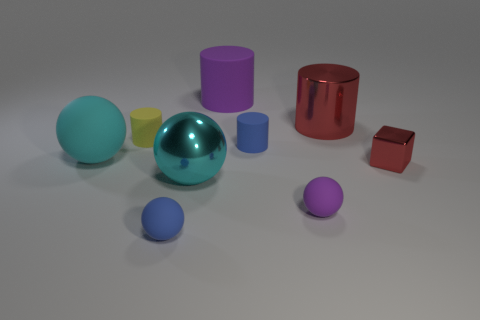What is the material of the small cylinder that is left of the big cyan ball that is in front of the big cyan thing that is left of the tiny yellow cylinder?
Your response must be concise. Rubber. There is a small blue thing behind the big rubber object left of the tiny yellow matte cylinder; what is it made of?
Make the answer very short. Rubber. Is the number of shiny cylinders that are left of the metallic cylinder less than the number of big cyan spheres?
Offer a terse response. Yes. What shape is the purple matte thing in front of the big red metallic cylinder?
Give a very brief answer. Sphere. Do the blue cylinder and the thing that is to the left of the yellow rubber cylinder have the same size?
Provide a succinct answer. No. Is there a tiny blue cylinder made of the same material as the purple ball?
Make the answer very short. Yes. How many cylinders are large purple matte things or large cyan matte things?
Provide a succinct answer. 1. Is there a cyan rubber thing that is in front of the red object that is right of the big red shiny object?
Your answer should be very brief. No. Are there fewer shiny balls than small yellow shiny spheres?
Make the answer very short. No. How many purple objects are the same shape as the tiny yellow matte thing?
Ensure brevity in your answer.  1. 